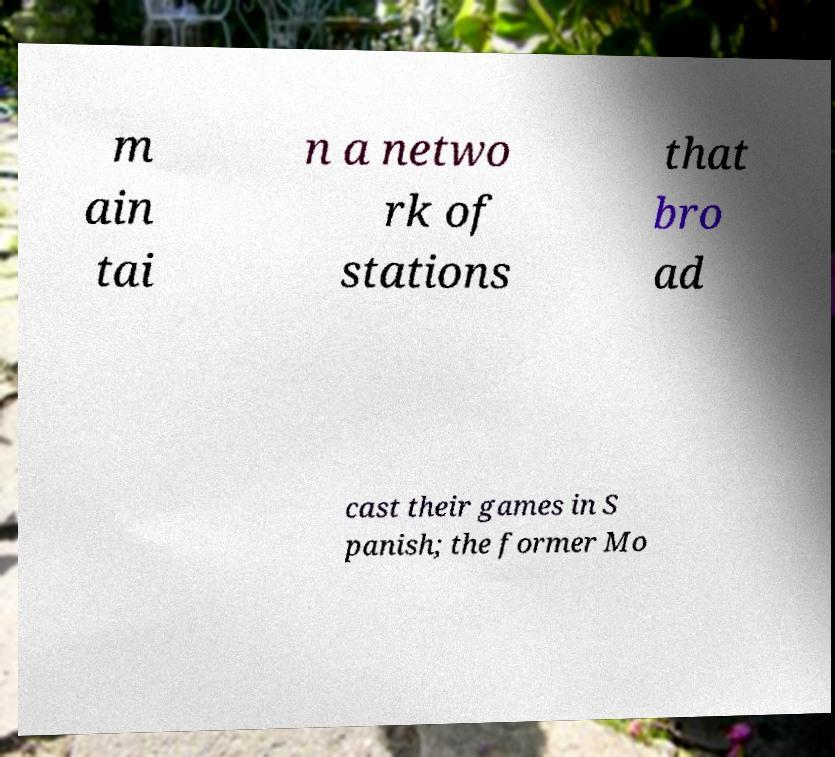There's text embedded in this image that I need extracted. Can you transcribe it verbatim? m ain tai n a netwo rk of stations that bro ad cast their games in S panish; the former Mo 